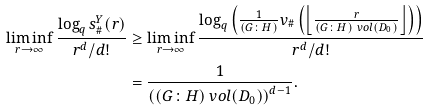Convert formula to latex. <formula><loc_0><loc_0><loc_500><loc_500>\liminf _ { r \to \infty } \frac { \log _ { q } s ^ { Y } _ { \# } ( r ) } { r ^ { d } / d ! } & \geq \liminf _ { r \to \infty } \frac { \log _ { q } \left ( \frac { 1 } { ( G \colon H ) } v _ { \# } \left ( \left \lfloor \frac { r } { ( G \colon H ) \ v o l ( D _ { 0 } ) } \right \rfloor \right ) \right ) } { r ^ { d } / d ! } \\ & = \frac { 1 } { \left ( ( G \colon H ) \ v o l ( D _ { 0 } ) \right ) ^ { d - 1 } } .</formula> 